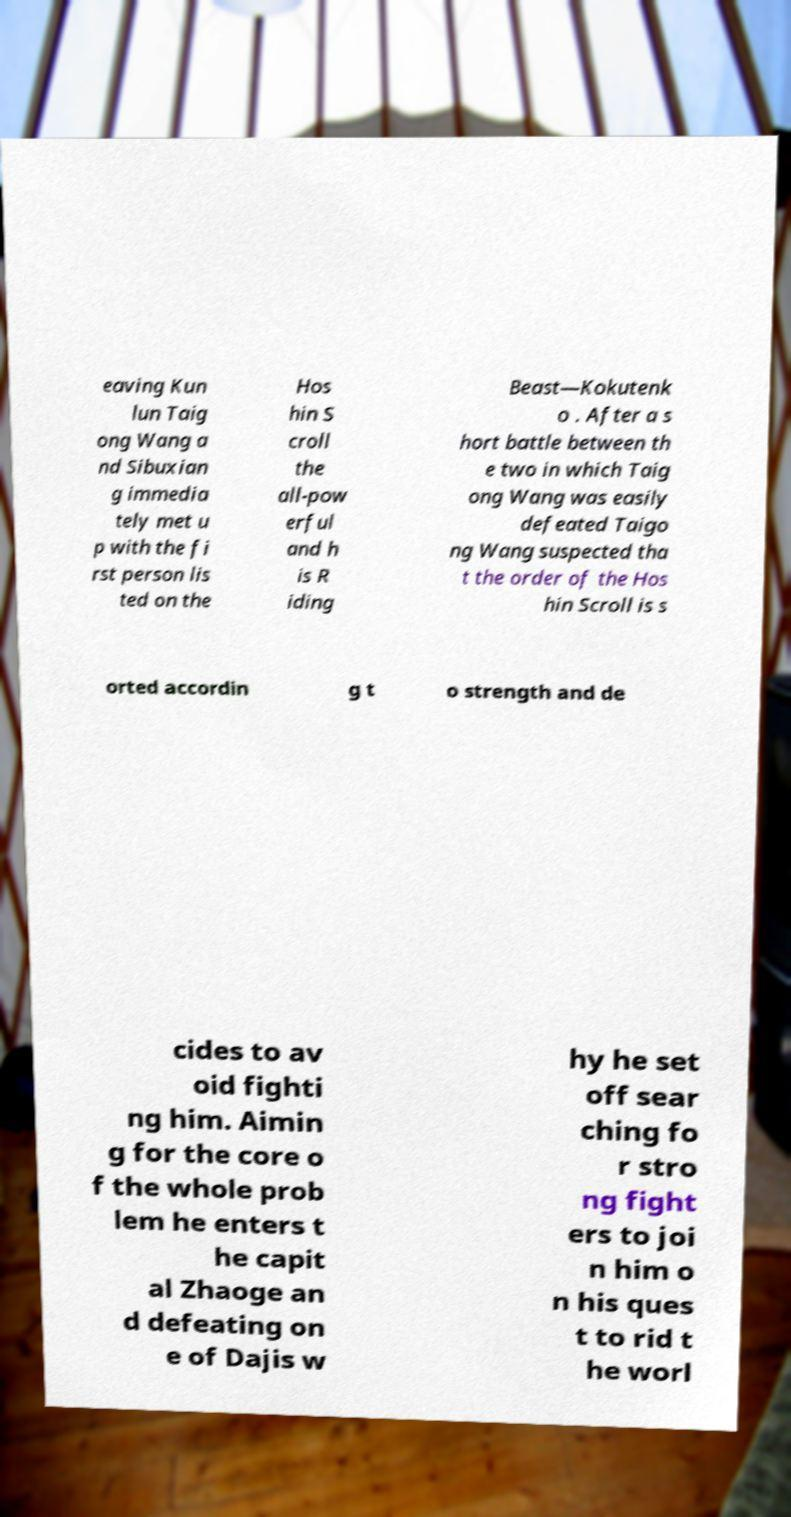Can you accurately transcribe the text from the provided image for me? eaving Kun lun Taig ong Wang a nd Sibuxian g immedia tely met u p with the fi rst person lis ted on the Hos hin S croll the all-pow erful and h is R iding Beast—Kokutenk o . After a s hort battle between th e two in which Taig ong Wang was easily defeated Taigo ng Wang suspected tha t the order of the Hos hin Scroll is s orted accordin g t o strength and de cides to av oid fighti ng him. Aimin g for the core o f the whole prob lem he enters t he capit al Zhaoge an d defeating on e of Dajis w hy he set off sear ching fo r stro ng fight ers to joi n him o n his ques t to rid t he worl 